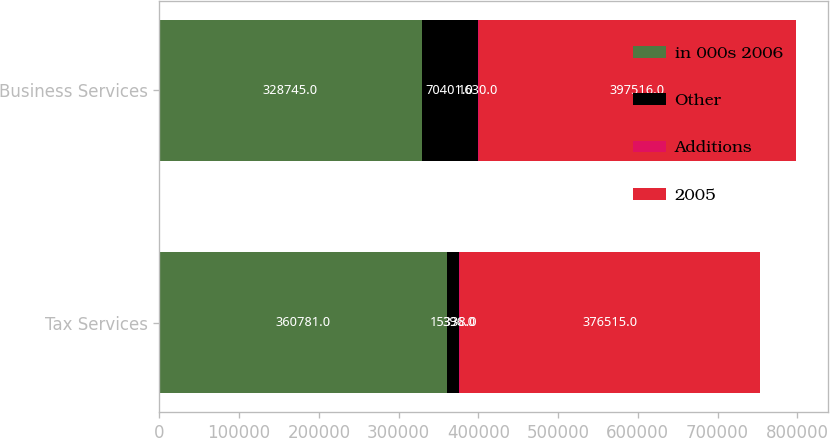<chart> <loc_0><loc_0><loc_500><loc_500><stacked_bar_chart><ecel><fcel>Tax Services<fcel>Business Services<nl><fcel>in 000s 2006<fcel>360781<fcel>328745<nl><fcel>Other<fcel>15338<fcel>70401<nl><fcel>Additions<fcel>396<fcel>1630<nl><fcel>2005<fcel>376515<fcel>397516<nl></chart> 